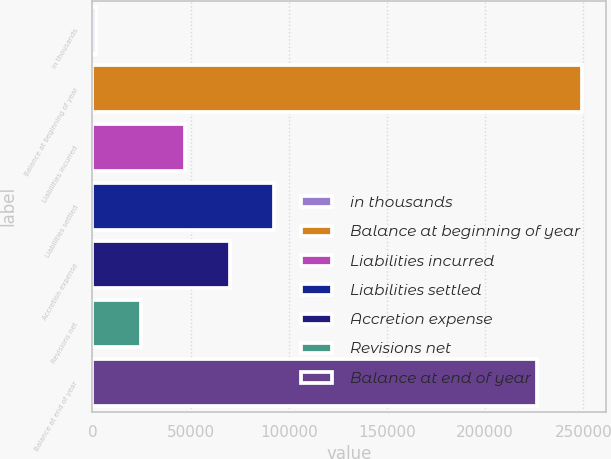Convert chart. <chart><loc_0><loc_0><loc_500><loc_500><bar_chart><fcel>in thousands<fcel>Balance at beginning of year<fcel>Liabilities incurred<fcel>Liabilities settled<fcel>Accretion expense<fcel>Revisions net<fcel>Balance at end of year<nl><fcel>2014<fcel>249187<fcel>47258<fcel>92502<fcel>69880<fcel>24636<fcel>226565<nl></chart> 